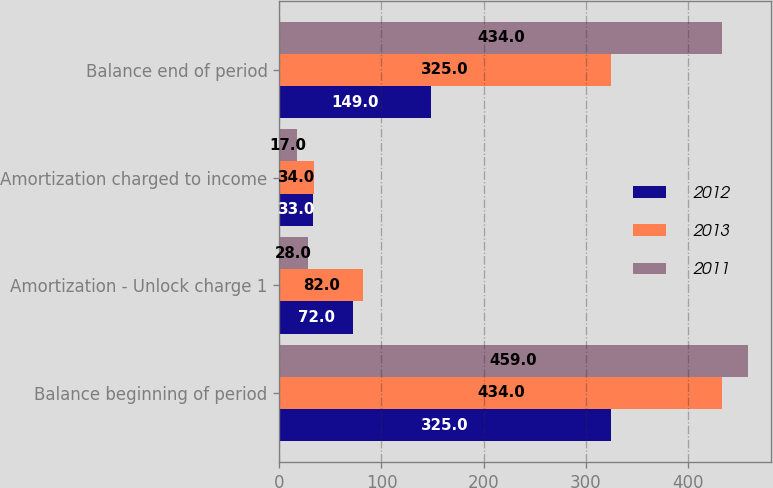<chart> <loc_0><loc_0><loc_500><loc_500><stacked_bar_chart><ecel><fcel>Balance beginning of period<fcel>Amortization - Unlock charge 1<fcel>Amortization charged to income<fcel>Balance end of period<nl><fcel>2012<fcel>325<fcel>72<fcel>33<fcel>149<nl><fcel>2013<fcel>434<fcel>82<fcel>34<fcel>325<nl><fcel>2011<fcel>459<fcel>28<fcel>17<fcel>434<nl></chart> 